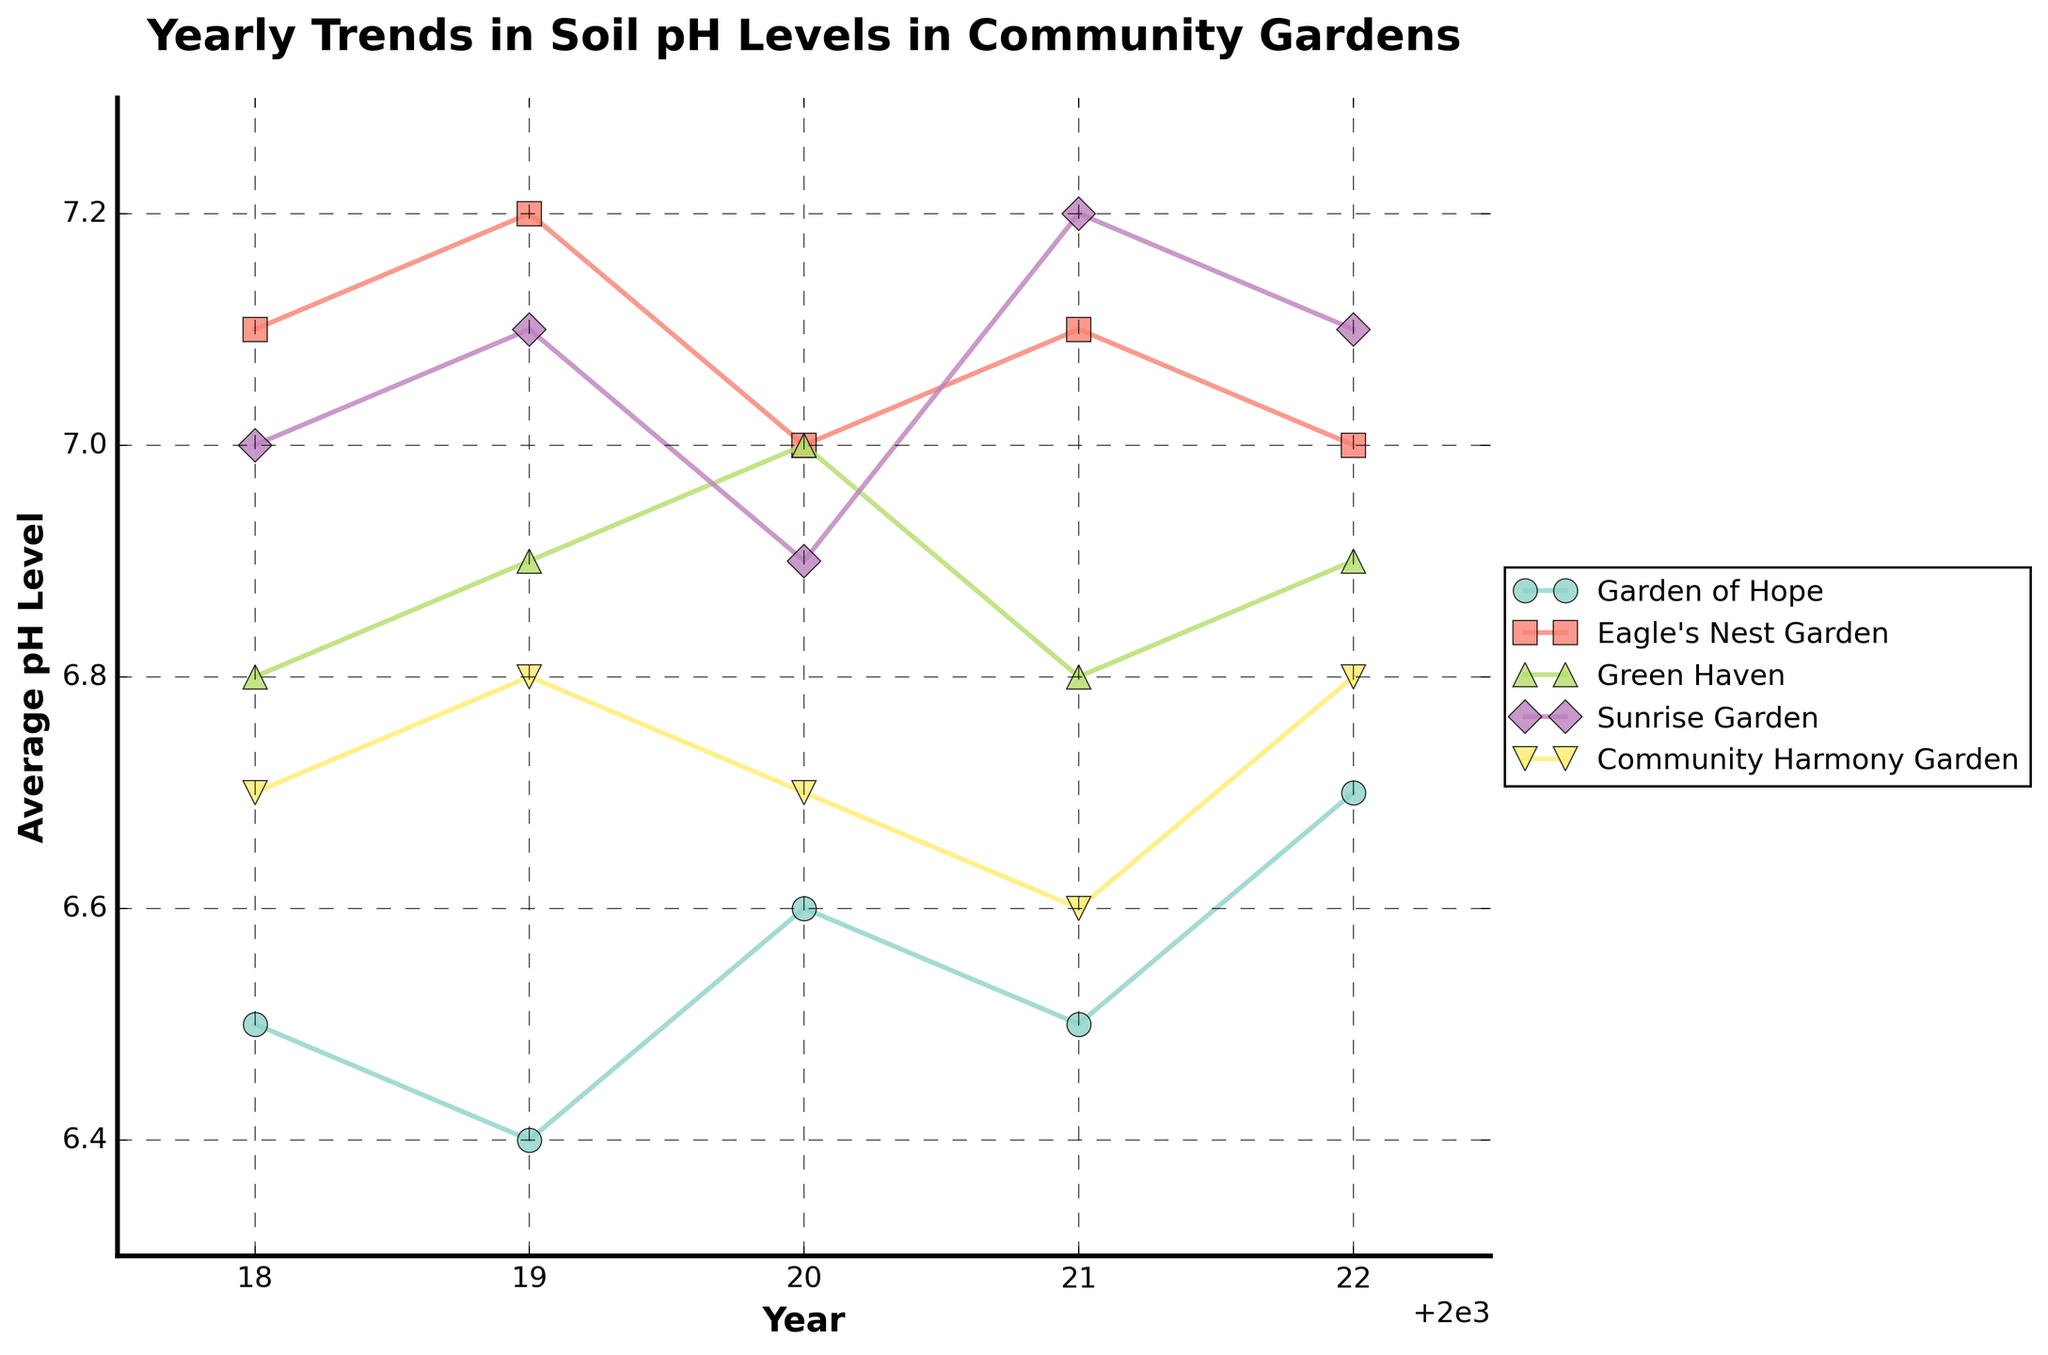What is the title of the figure? The title of the figure is typically located at the top of the plot and is meant to provide an overview of what the plot represents. In this case, it is clearly stated at the top of the plot.
Answer: Yearly Trends in Soil pH Levels in Community Gardens Which garden had the highest average pH level in 2018? To find which garden had the highest average pH level in 2018, you look at the data points for each garden for the year 2018 and compare their values. Eagle's Nest Garden has the highest value.
Answer: Eagle's Nest Garden What was the average pH level for Sunrise Garden in 2020? Find the data point for Sunrise Garden in the year 2020 and read its corresponding average pH level value.
Answer: 6.9 Which garden showed a decreasing pH trend from 2019 to 2020? Examine the pH values between 2019 and 2020 for all gardens. Identify the gardens whose pH level decreased between these two years. Eagle's Nest Garden and Sunrise Garden showed a decrease.
Answer: Eagle's Nest Garden, Sunrise Garden What is the overall trend in the average pH levels for Garden of Hope from 2018 to 2022? Observe the data points for Garden of Hope from 2018 to 2022 and analyze if the pH levels are increasing, decreasing, or remaining constant. There is a slight increase over the years.
Answer: Slightly increasing How many gardens have pH levels within the range of 6.7 to 7.0 in 2022? Look at the pH values for each garden in the year 2022 and count how many fall within the range of 6.7 to 7.0. Community Harmony Garden, Eagle's Nest Garden, Green Haven, and Sunrise Garden are within this range.
Answer: 4 Which garden had the most stable pH level from 2018 to 2022? To determine the most stable garden, compare the variation in pH levels for each garden over the years. A garden with minimal variation is considered stable. Green Haven shows the least variation.
Answer: Green Haven Between which years did Eagle's Nest Garden’s pH level show the most significant change? Calculate the difference in pH level for each year-to-year transition for Eagle’s Nest Garden and find the largest change. The most significant change is between 2019 and 2020.
Answer: 2019 to 2020 Is there any garden whose pH level returns to its initial 2018 value in 2022? Compare the 2018 and 2022 pH levels for each garden to see if any pH level values are the same for both years. Community Harmony Garden’s pH level returns to its initial value.
Answer: Community Harmony Garden 